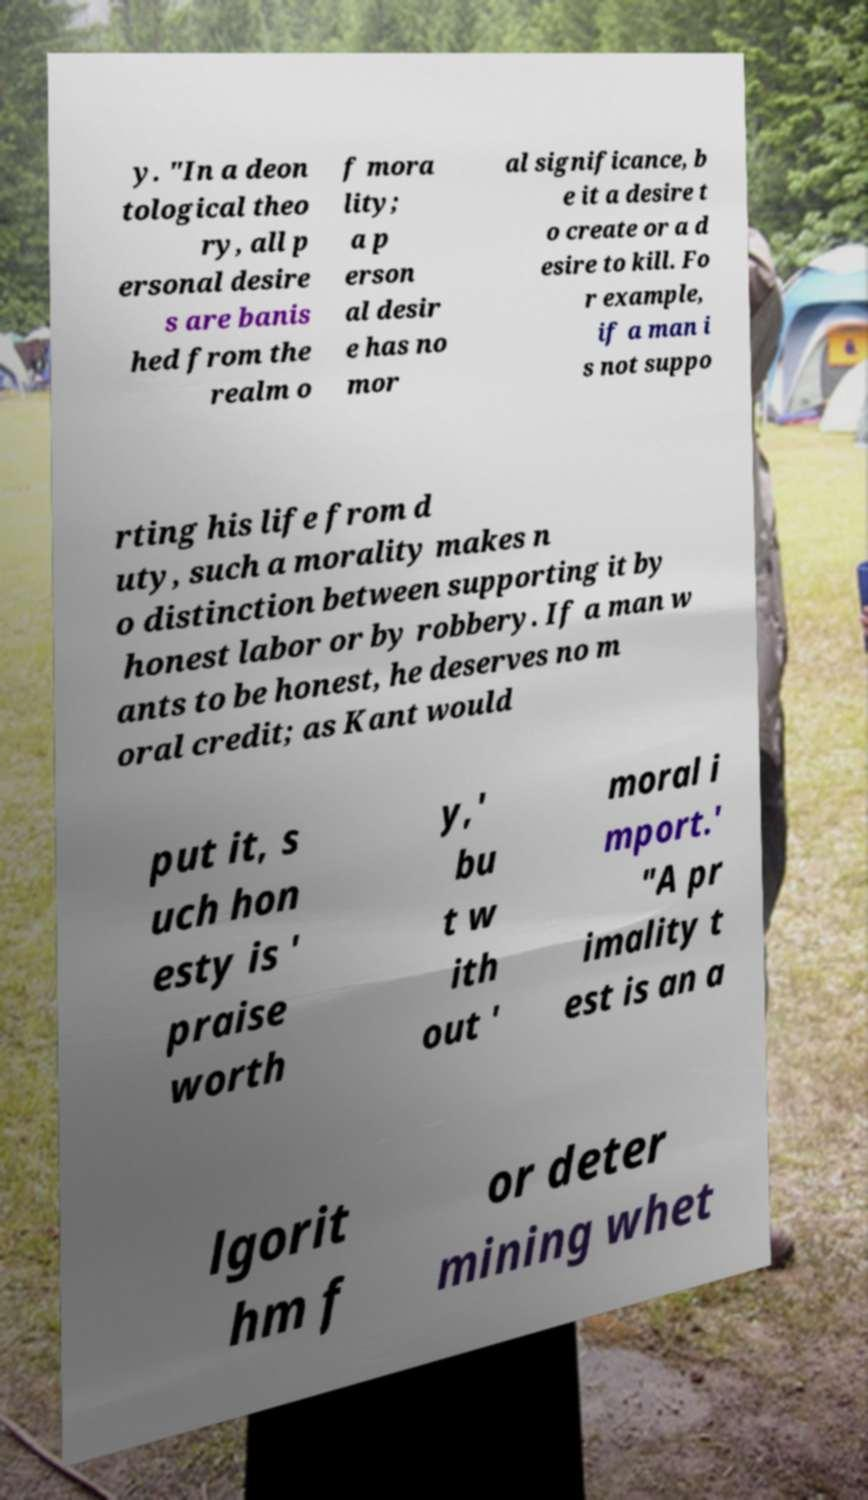Can you read and provide the text displayed in the image?This photo seems to have some interesting text. Can you extract and type it out for me? y. "In a deon tological theo ry, all p ersonal desire s are banis hed from the realm o f mora lity; a p erson al desir e has no mor al significance, b e it a desire t o create or a d esire to kill. Fo r example, if a man i s not suppo rting his life from d uty, such a morality makes n o distinction between supporting it by honest labor or by robbery. If a man w ants to be honest, he deserves no m oral credit; as Kant would put it, s uch hon esty is ' praise worth y,' bu t w ith out ' moral i mport.' "A pr imality t est is an a lgorit hm f or deter mining whet 